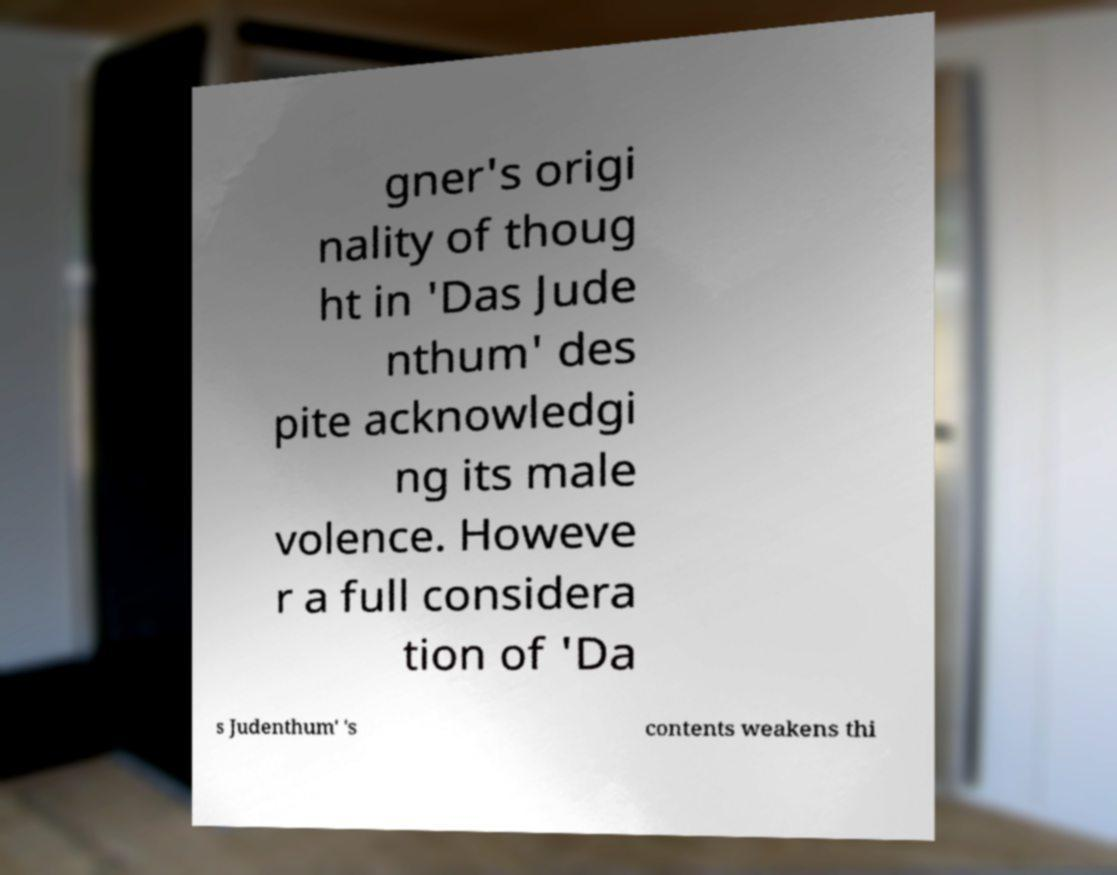Can you read and provide the text displayed in the image?This photo seems to have some interesting text. Can you extract and type it out for me? gner's origi nality of thoug ht in 'Das Jude nthum' des pite acknowledgi ng its male volence. Howeve r a full considera tion of 'Da s Judenthum' 's contents weakens thi 